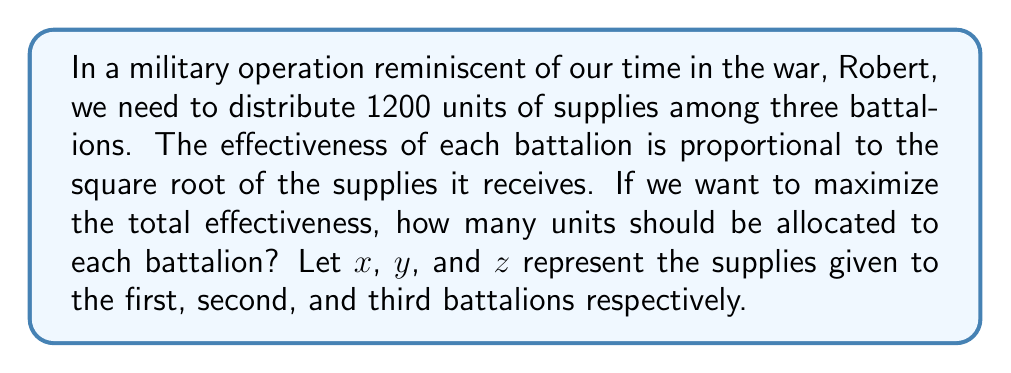Give your solution to this math problem. 1) We need to maximize the total effectiveness, which is given by:
   $$E = \sqrt{x} + \sqrt{y} + \sqrt{z}$$

2) Subject to the constraint:
   $$x + y + z = 1200$$

3) This is an optimization problem that can be solved using the method of Lagrange multipliers. Let's define the Lagrangian:
   $$L = \sqrt{x} + \sqrt{y} + \sqrt{z} - \lambda(x + y + z - 1200)$$

4) Taking partial derivatives and setting them to zero:
   $$\frac{\partial L}{\partial x} = \frac{1}{2\sqrt{x}} - \lambda = 0$$
   $$\frac{\partial L}{\partial y} = \frac{1}{2\sqrt{y}} - \lambda = 0$$
   $$\frac{\partial L}{\partial z} = \frac{1}{2\sqrt{z}} - \lambda = 0$$
   $$\frac{\partial L}{\partial \lambda} = x + y + z - 1200 = 0$$

5) From the first three equations, we can deduce:
   $$\frac{1}{2\sqrt{x}} = \frac{1}{2\sqrt{y}} = \frac{1}{2\sqrt{z}} = \lambda$$

6) This implies that $x = y = z$

7) Substituting this into the constraint equation:
   $$3x = 1200$$

8) Solving for x:
   $$x = y = z = 400$$

Therefore, to maximize the total effectiveness, we should distribute the supplies equally among the three battalions.
Answer: 400 units to each battalion 